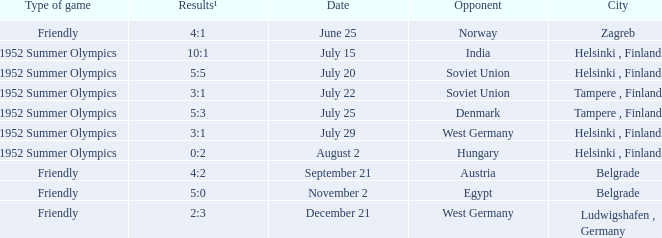What Type of game was played on Date of July 29? 1952 Summer Olympics. 